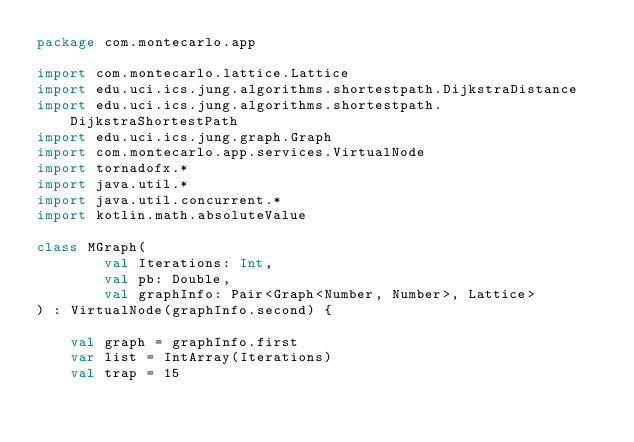<code> <loc_0><loc_0><loc_500><loc_500><_Kotlin_>package com.montecarlo.app

import com.montecarlo.lattice.Lattice
import edu.uci.ics.jung.algorithms.shortestpath.DijkstraDistance
import edu.uci.ics.jung.algorithms.shortestpath.DijkstraShortestPath
import edu.uci.ics.jung.graph.Graph
import com.montecarlo.app.services.VirtualNode
import tornadofx.*
import java.util.*
import java.util.concurrent.*
import kotlin.math.absoluteValue

class MGraph(
        val Iterations: Int,
        val pb: Double,
        val graphInfo: Pair<Graph<Number, Number>, Lattice>
) : VirtualNode(graphInfo.second) {

    val graph = graphInfo.first
    var list = IntArray(Iterations)
    val trap = 15</code> 